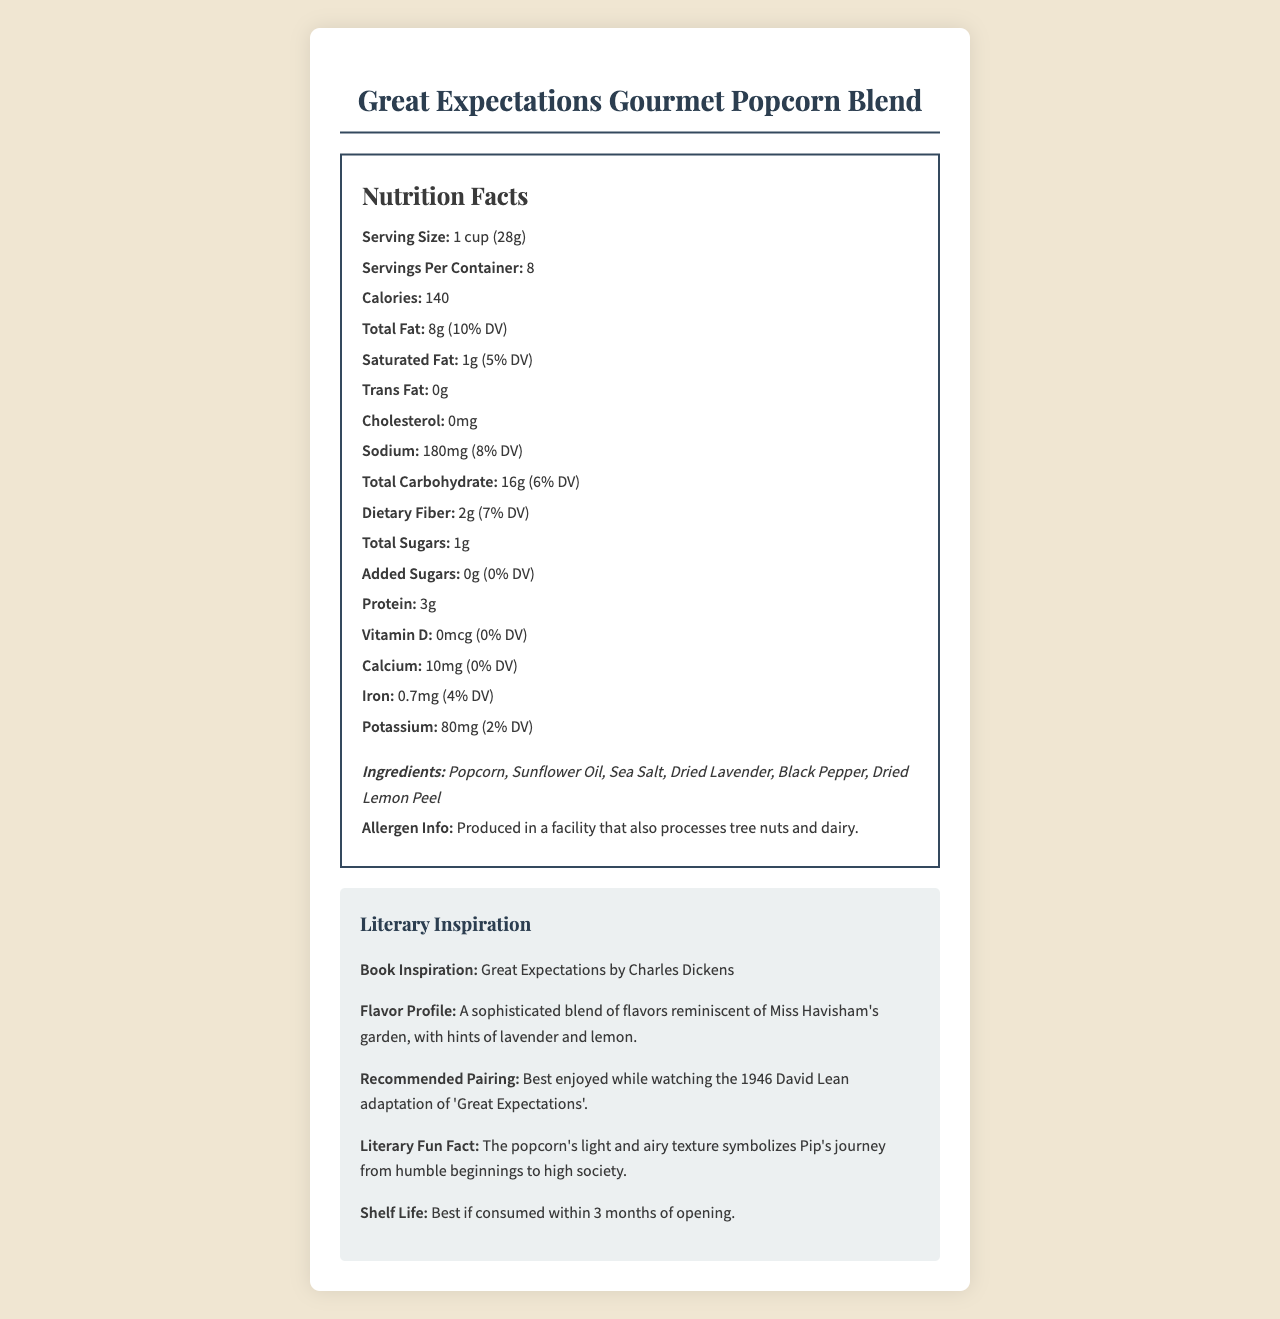what is the serving size? The serving size is listed as "1 cup (28g)" in the Nutrition Facts section of the document.
Answer: 1 cup (28g) how many calories are in one serving? The document specifies that one serving contains 140 calories.
Answer: 140 what is the daily value percentage for saturated fat? The daily value percentage for saturated fat is indicated as 5%.
Answer: 5% how much cholesterol does this product have? The label states that there is 0mg of cholesterol in this product.
Answer: 0mg what is the recommended pairing for this product? The Literary Inspiration section mentions that the popcorn blend is best enjoyed while watching the 1946 David Lean adaptation of "Great Expectations."
Answer: Best enjoyed while watching the 1946 David Lean adaptation of 'Great Expectations'. how much dietary fiber is in one serving? The label lists the dietary fiber content as 2g per serving with a daily value of 7%.
Answer: 2g which ingredient is not included in the list? A. Sunflower Oil B. Sea Salt C. Butter D. Dried Lemon Peel The ingredients listed are Popcorn, Sunflower Oil, Sea Salt, Dried Lavender, Black Pepper, and Dried Lemon Peel. Butter is not included.
Answer: C. Butter what is the shelf life of the product? A. 1 month B. 3 months C. 6 months D. 12 months The document states that the product is best if consumed within 3 months of opening.
Answer: B. 3 months is the product allergen-free? The document notes that the product is produced in a facility that also processes tree nuts and dairy, indicating potential allergen exposure.
Answer: No summarize the document The summary captures the main points: nutritional facts, ingredients, allergen info, literary inspiration, flavor profile, recommended pairing, and shelf life.
Answer: The document provides nutritional information and literary inspiration for Great Expectations Gourmet Popcorn Blend. It details serving size, calorie count, and nutrient content, along with ingredients and allergen info. The blend is inspired by the novel "Great Expectations" with a flavor profile reminiscent of Miss Havisham's garden. It is recommended to be enjoyed while watching the 1946 film adaptation and has a shelf life of 3 months. what is the vitamin C content in this product? The document does not provide any information regarding the vitamin C content in the product.
Answer: Not enough information 